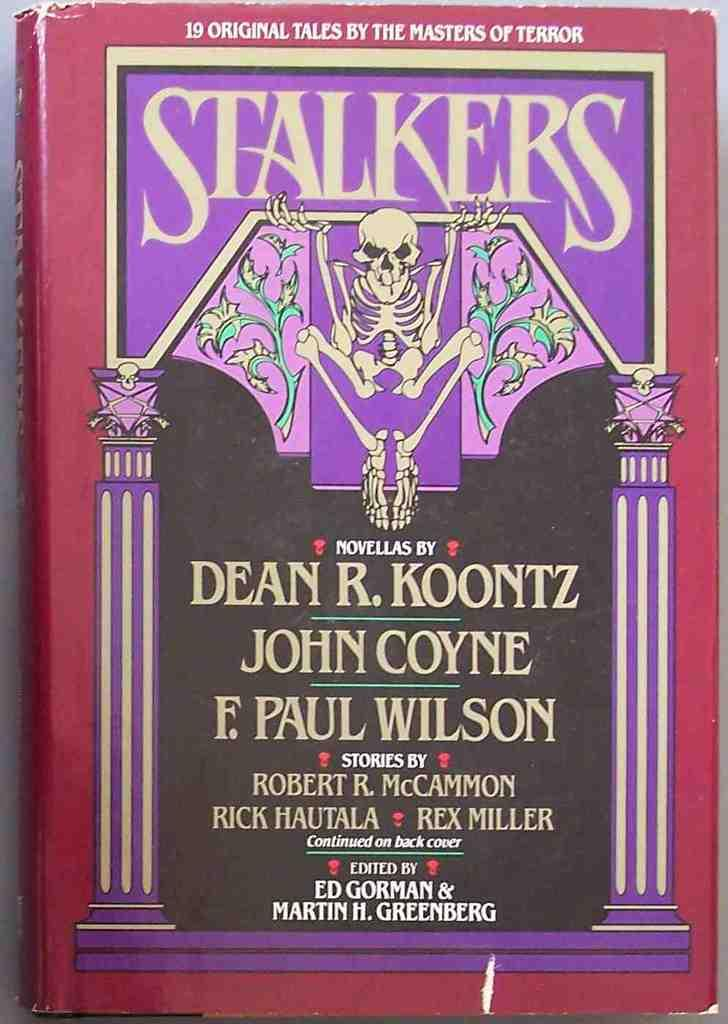<image>
Provide a brief description of the given image. A book called Stalkers by Robert R. McCammon, Rick Hautala and Rex Miller. 